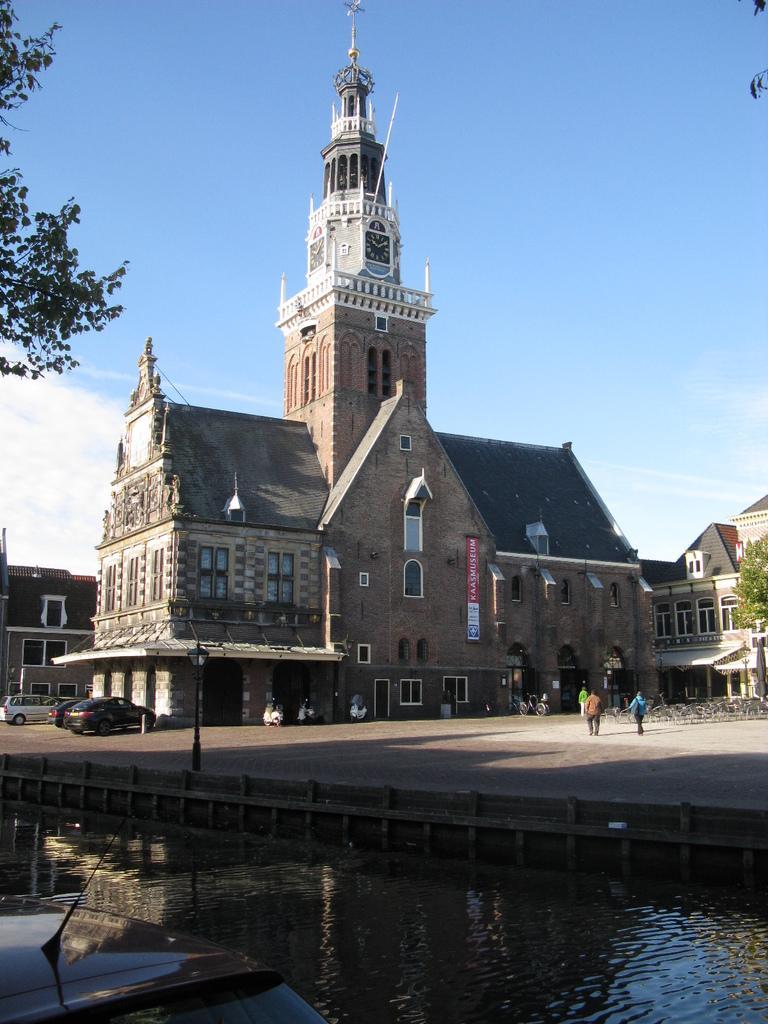Describe this image in one or two sentences. In the bottom left corner of the image we can see a vehicle. In the bottom right corner of the image we can see water. In the middle of the image we can see some poles, vehicles and few people are walking. In front of them we can see some buildings. At the top of the image we can see some clouds in the sky. In the top left corner of the image we can see a tree. 